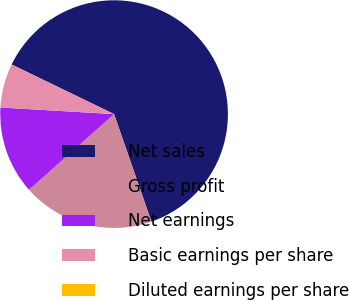<chart> <loc_0><loc_0><loc_500><loc_500><pie_chart><fcel>Net sales<fcel>Gross profit<fcel>Net earnings<fcel>Basic earnings per share<fcel>Diluted earnings per share<nl><fcel>62.5%<fcel>18.75%<fcel>12.5%<fcel>6.25%<fcel>0.0%<nl></chart> 